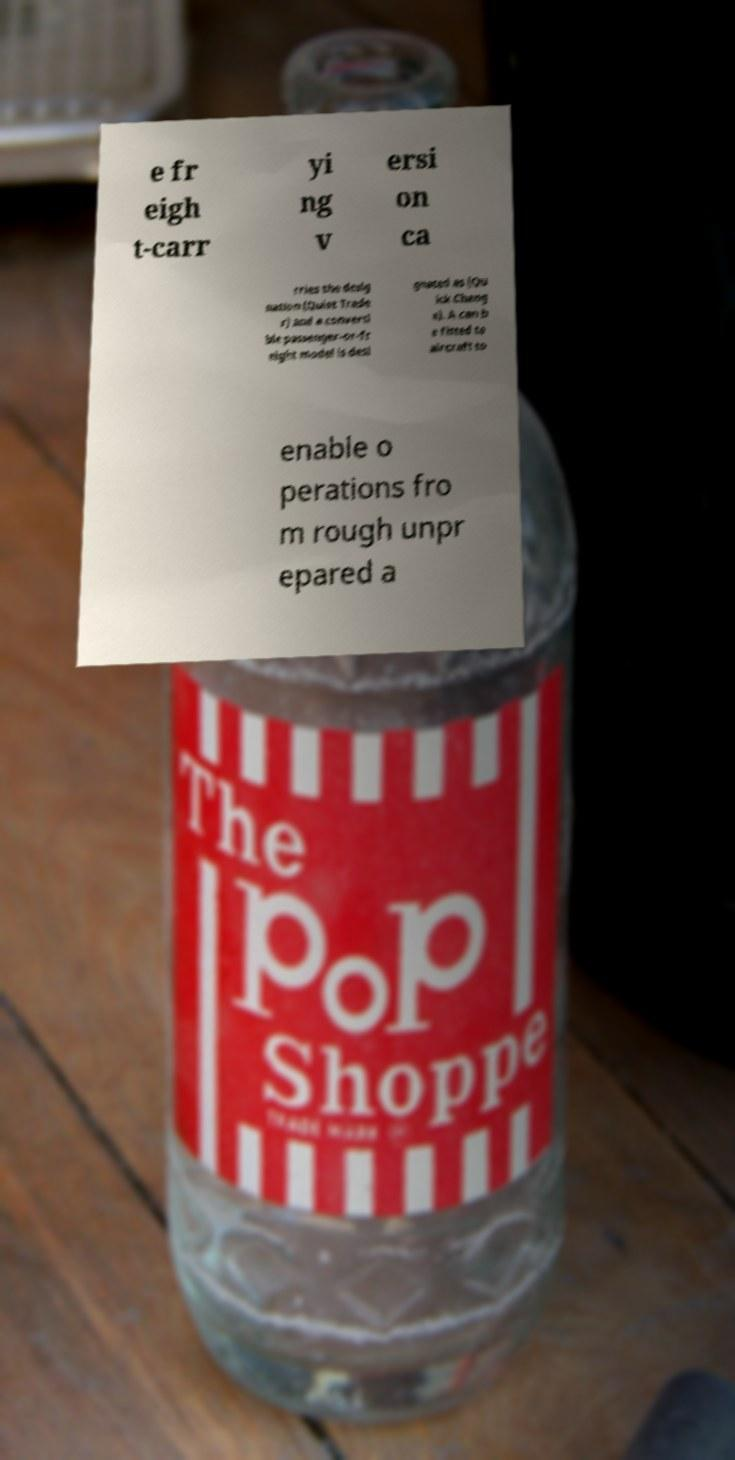For documentation purposes, I need the text within this image transcribed. Could you provide that? e fr eigh t-carr yi ng v ersi on ca rries the desig nation (Quiet Trade r) and a converti ble passenger-or-fr eight model is desi gnated as (Qu ick Chang e). A can b e fitted to aircraft to enable o perations fro m rough unpr epared a 